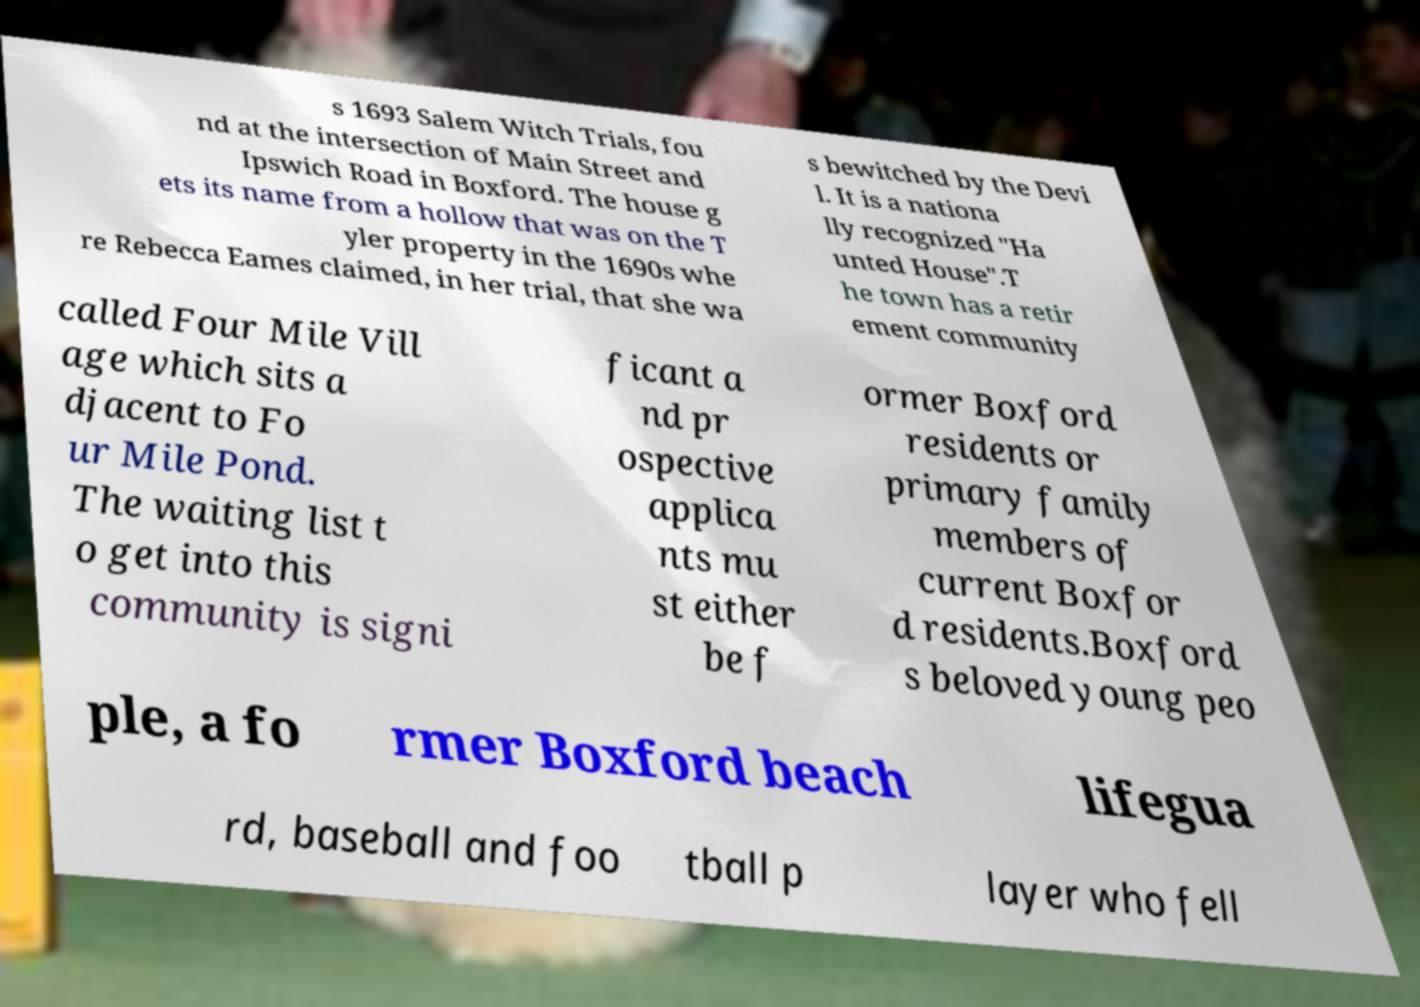Can you read and provide the text displayed in the image?This photo seems to have some interesting text. Can you extract and type it out for me? s 1693 Salem Witch Trials, fou nd at the intersection of Main Street and Ipswich Road in Boxford. The house g ets its name from a hollow that was on the T yler property in the 1690s whe re Rebecca Eames claimed, in her trial, that she wa s bewitched by the Devi l. It is a nationa lly recognized "Ha unted House".T he town has a retir ement community called Four Mile Vill age which sits a djacent to Fo ur Mile Pond. The waiting list t o get into this community is signi ficant a nd pr ospective applica nts mu st either be f ormer Boxford residents or primary family members of current Boxfor d residents.Boxford s beloved young peo ple, a fo rmer Boxford beach lifegua rd, baseball and foo tball p layer who fell 